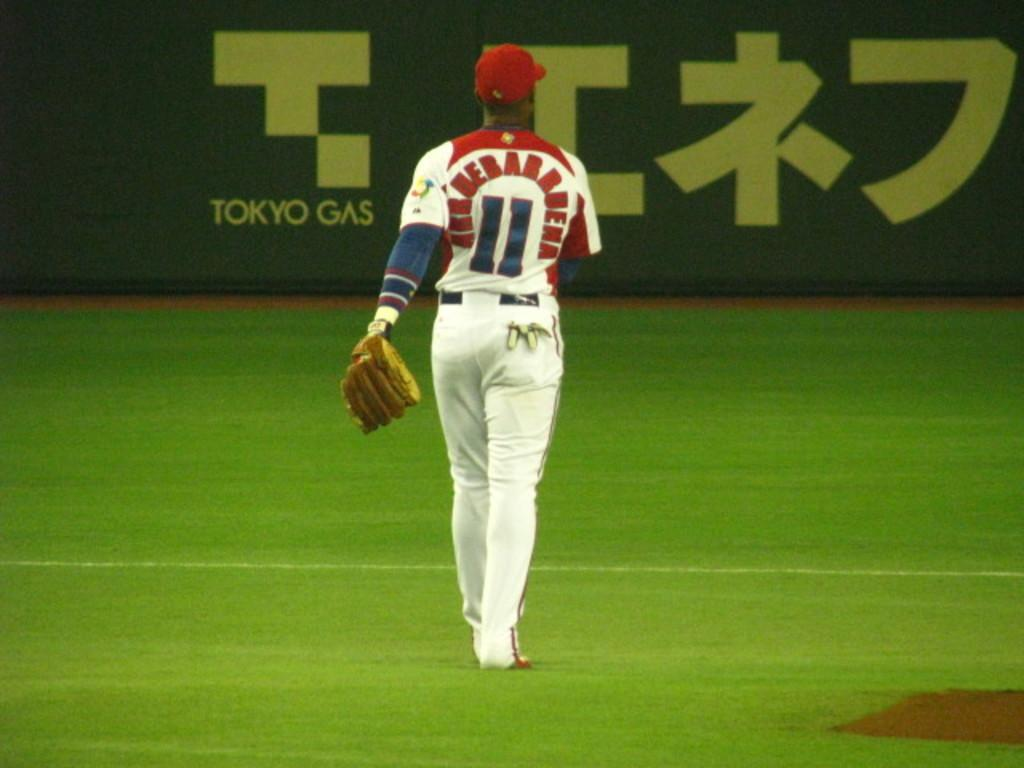<image>
Offer a succinct explanation of the picture presented. Baseball player in the outfield wearing a jersey saying: Arruebabbuena # 11. 